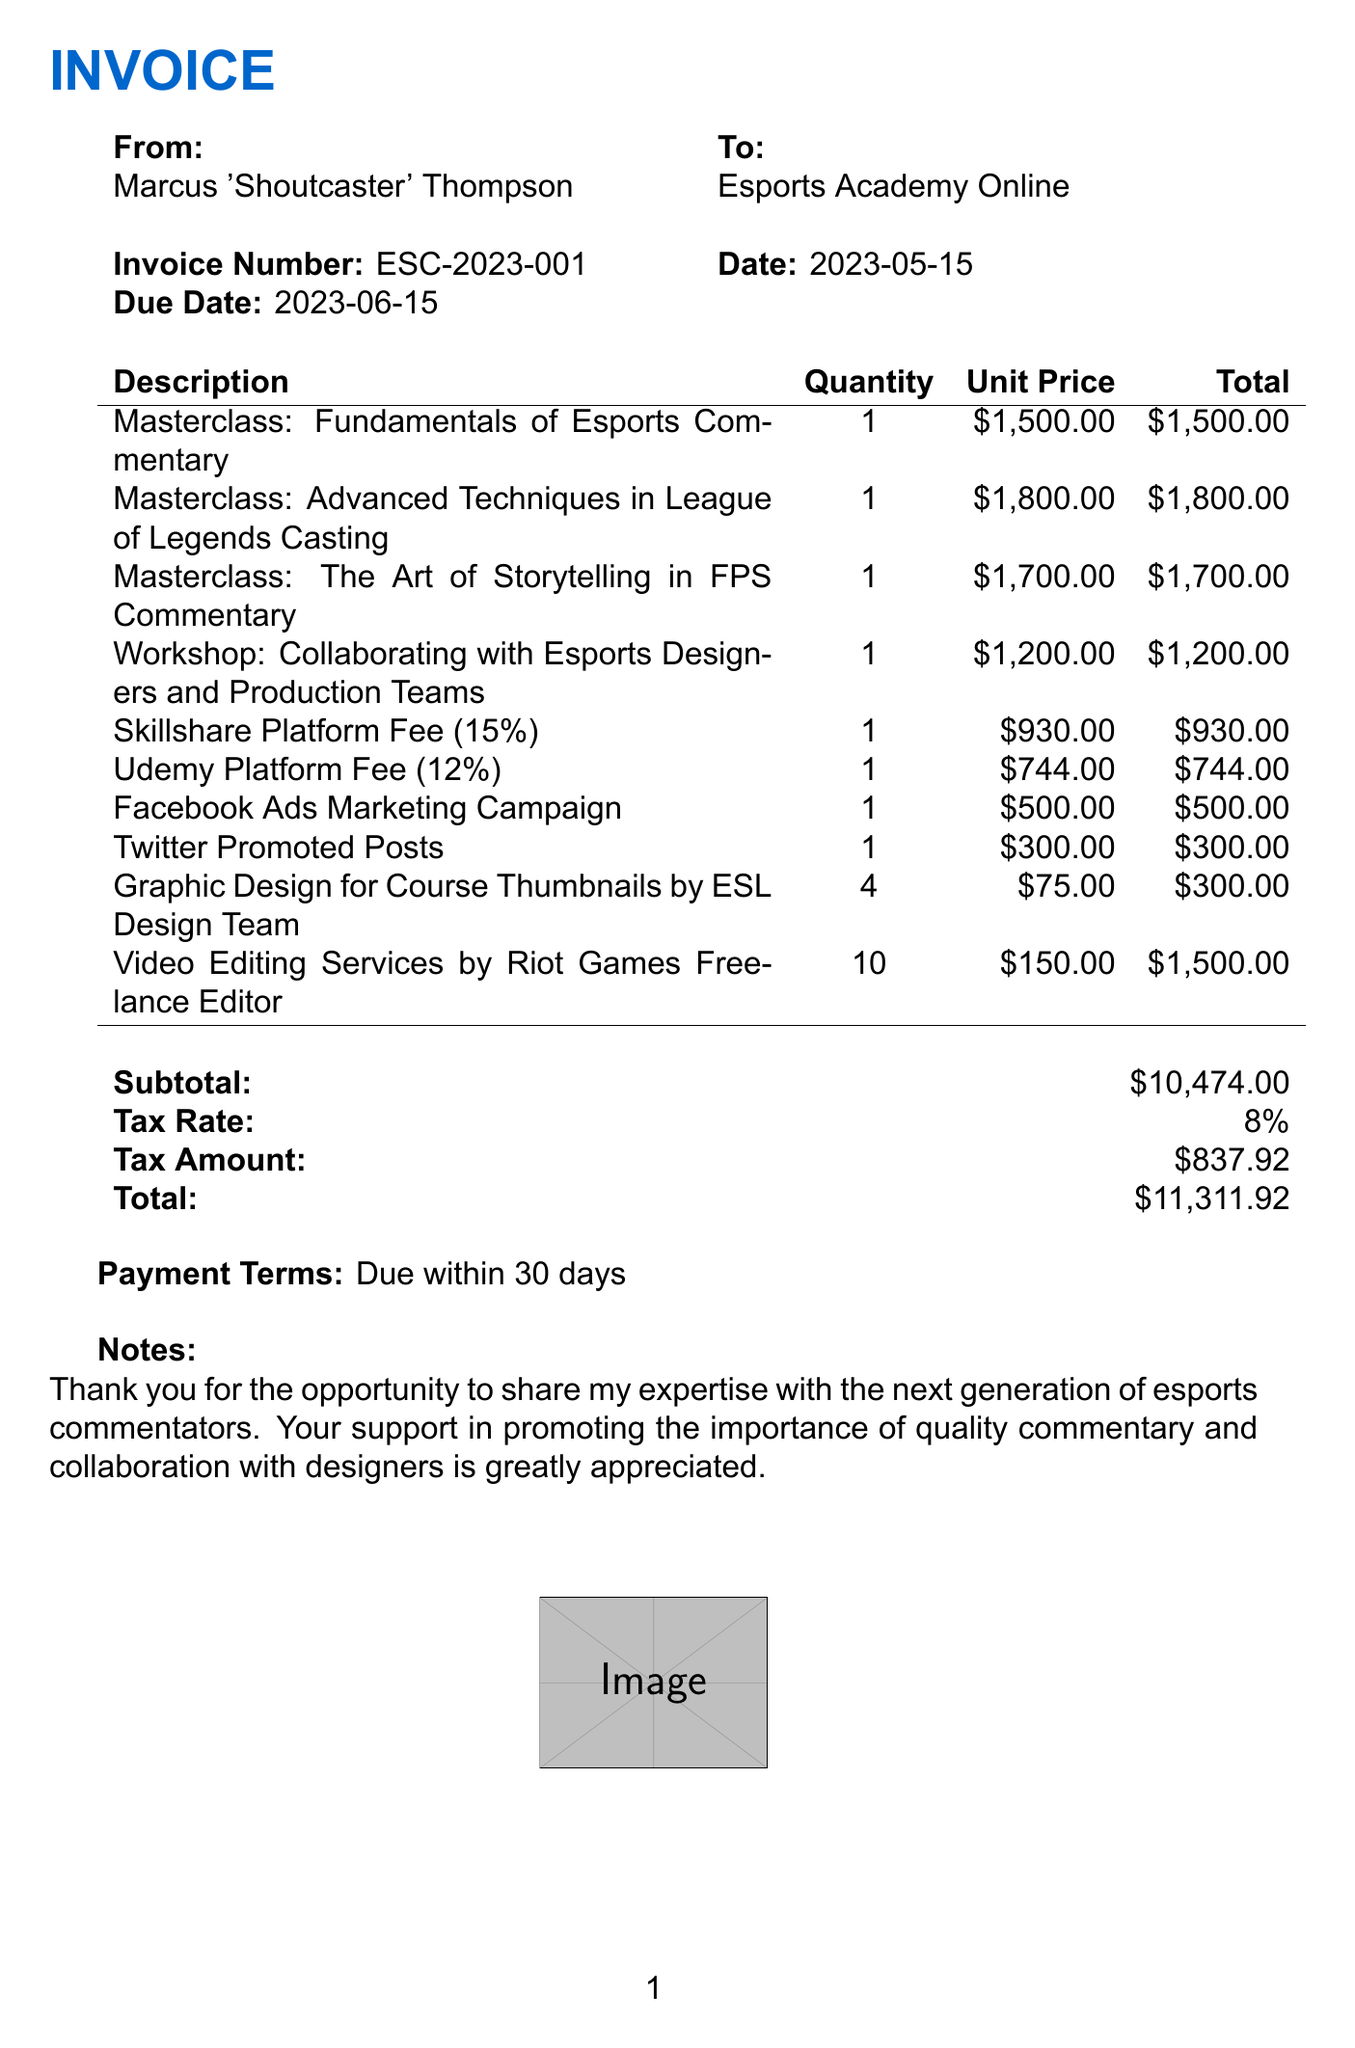What is the invoice number? The invoice number is specified at the top of the document under invoice details.
Answer: ESC-2023-001 What is the due date for the invoice? The due date is indicated next to the invoice date in the document.
Answer: 2023-06-15 How many masterclasses are listed in the invoice? The invoice lists individual masterclasses that are itemized in the document.
Answer: 3 What is the subtotal amount before tax? The subtotal is provided at the end of the itemized sections above tax calculations.
Answer: 10474.00 What percentage is the tax rate? The tax rate is stated clearly in the table for calculations related to total costs.
Answer: 8% What is the total amount due on the invoice? The total amount is the final amount shown at the bottom of the invoice after tax.
Answer: 11311.92 Who is the sender of the invoice? The sender's name is mentioned in the invoice details section.
Answer: Marcus 'Shoutcaster' Thompson What is the payment term stated in the invoice? Payment terms are specified at the end of the invoice, indicating when payment is expected.
Answer: Due within 30 days What service is highlighted in the notes section? The notes section expresses appreciation for collaboration and sharing expertise in commentary fields.
Answer: Quality commentary and collaboration with designers 